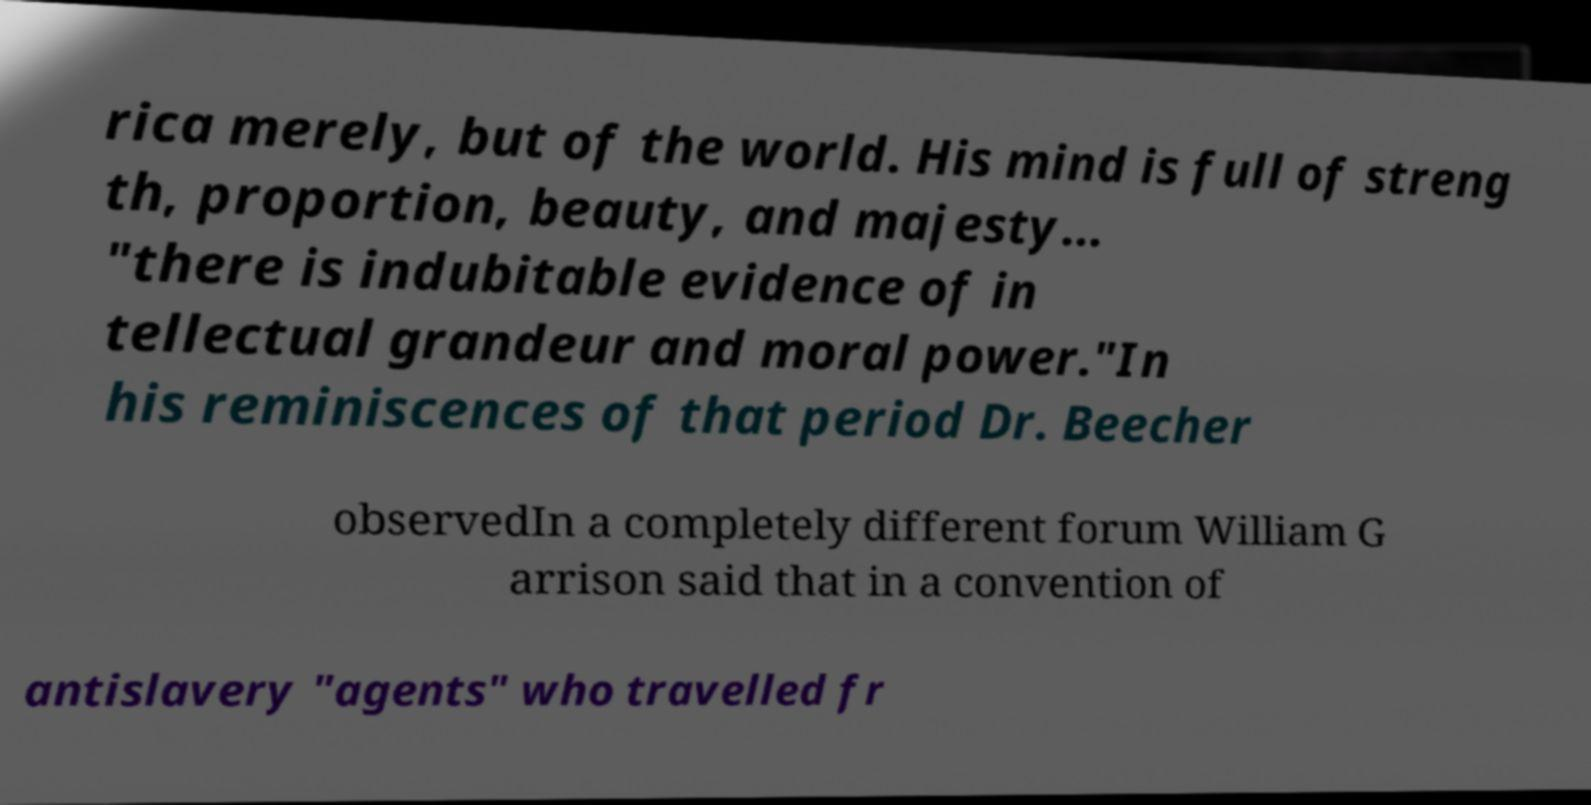I need the written content from this picture converted into text. Can you do that? rica merely, but of the world. His mind is full of streng th, proportion, beauty, and majesty... "there is indubitable evidence of in tellectual grandeur and moral power."In his reminiscences of that period Dr. Beecher observedIn a completely different forum William G arrison said that in a convention of antislavery "agents" who travelled fr 